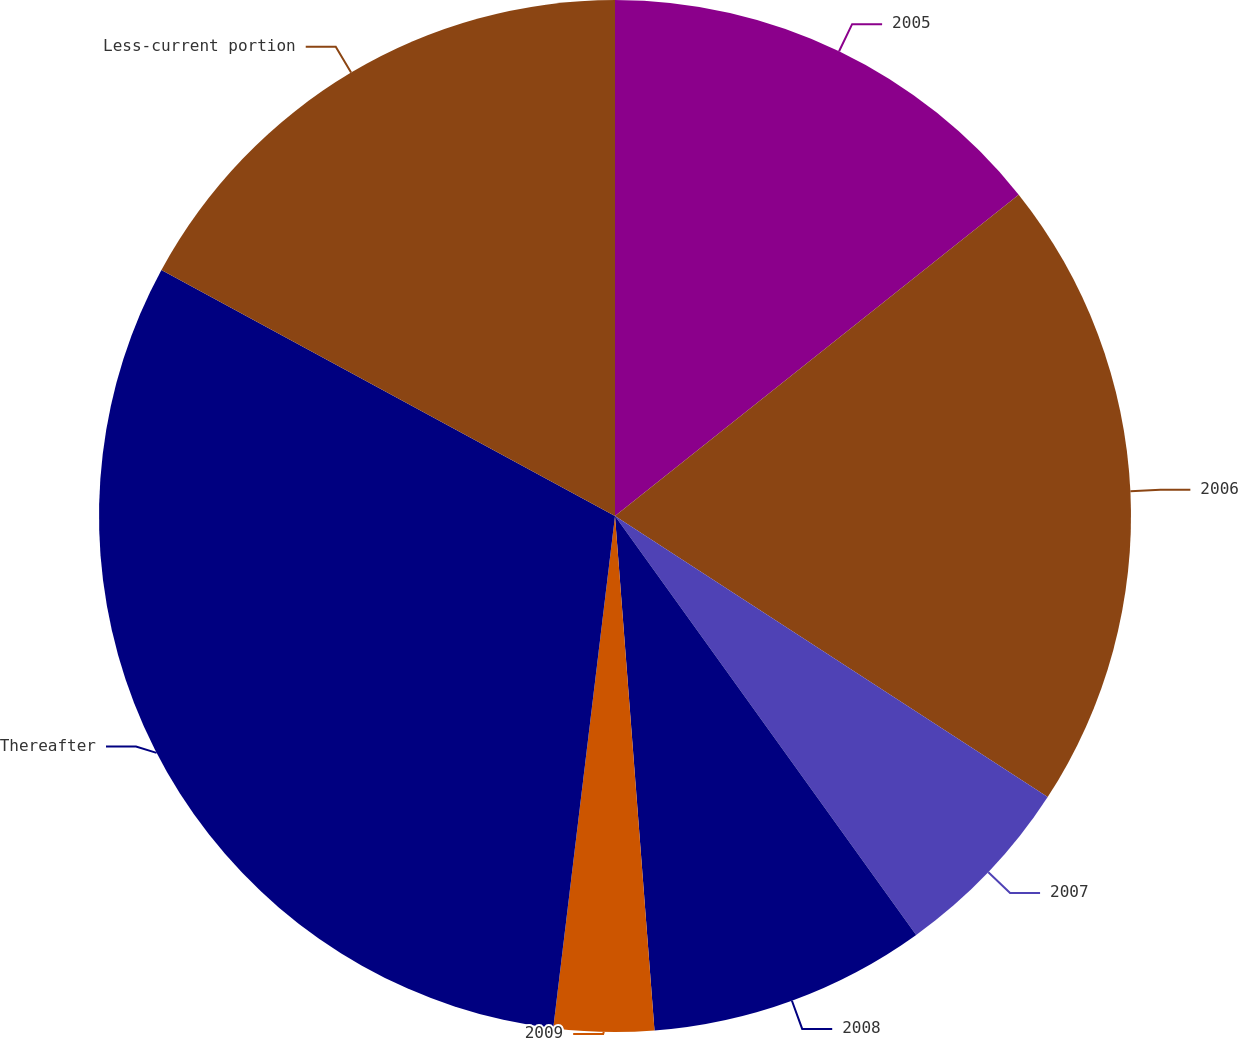Convert chart. <chart><loc_0><loc_0><loc_500><loc_500><pie_chart><fcel>2005<fcel>2006<fcel>2007<fcel>2008<fcel>2009<fcel>Thereafter<fcel>Less-current portion<nl><fcel>14.3%<fcel>19.87%<fcel>5.91%<fcel>8.7%<fcel>3.13%<fcel>31.0%<fcel>17.09%<nl></chart> 